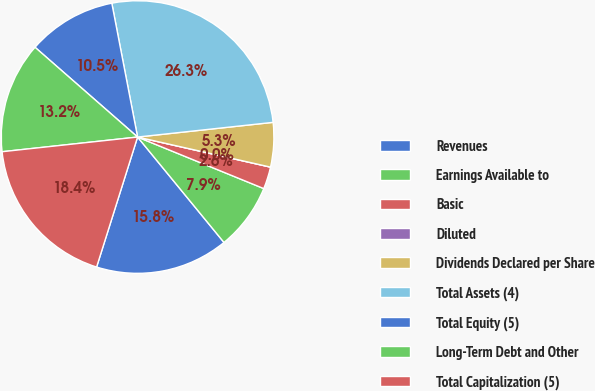Convert chart. <chart><loc_0><loc_0><loc_500><loc_500><pie_chart><fcel>Revenues<fcel>Earnings Available to<fcel>Basic<fcel>Diluted<fcel>Dividends Declared per Share<fcel>Total Assets (4)<fcel>Total Equity (5)<fcel>Long-Term Debt and Other<fcel>Total Capitalization (5)<nl><fcel>15.79%<fcel>7.9%<fcel>2.63%<fcel>0.0%<fcel>5.26%<fcel>26.31%<fcel>10.53%<fcel>13.16%<fcel>18.42%<nl></chart> 